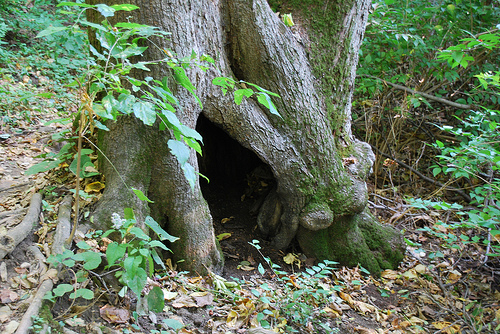<image>
Is there a hole in the tree? Yes. The hole is contained within or inside the tree, showing a containment relationship. 